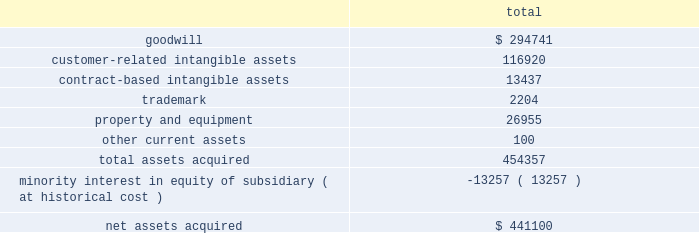Notes to consolidated financial statements 2014 ( continued ) merchant acquiring business in the united kingdom to the partnership .
In addition , hsbc uk entered into a ten-year marketing alliance with the partnership in which hsbc uk will refer customers to the partnership for payment processing services in the united kingdom .
On june 23 , 2008 , we entered into a new five year , $ 200 million term loan to fund a portion of the acquisition .
We funded the remaining purchase price with excess cash and our existing credit facilities .
The term loan bears interest , at our election , at the prime rate or london interbank offered rate plus a margin based on our leverage position .
As of july 1 , 2008 , the interest rate on the term loan was 3.605% ( 3.605 % ) .
The term loan calls for quarterly principal payments of $ 5 million beginning with the quarter ending august 31 , 2008 and increasing to $ 10 million beginning with the quarter ending august 31 , 2010 and $ 15 million beginning with the quarter ending august 31 , 2011 .
The partnership agreement includes provisions pursuant to which hsbc uk may compel us to purchase , at fair value , additional membership units from hsbc uk ( the 201cput option 201d ) .
Hsbc uk may exercise the put option on the fifth anniversary of the closing of the acquisition and on each anniversary thereafter .
By exercising the put option , hsbc uk can require us to purchase , on an annual basis , up to 15% ( 15 % ) of the total membership units .
Additionally , on the tenth anniversary of closing and each tenth anniversary thereafter , hsbc uk may compel us to purchase all of their membership units at fair value .
While not redeemable until june 2013 , we estimate the maximum total redemption amount of the minority interest under the put option would be $ 421.4 million , as of may 31 , 2008 .
The purpose of this acquisition was to establish a presence in the united kingdom .
The key factors that contributed to the decision to make this acquisition include historical and prospective financial statement analysis and hsbc uk 2019s market share and retail presence in the united kingdom .
The purchase price was determined by analyzing the historical and prospective financial statements and applying relevant purchase price multiples .
The purchase price totaled $ 441.1 million , consisting of $ 438.6 million cash consideration plus $ 2.5 million of direct out of pocket costs .
The acquisition has been recorded using the purchase method of accounting , and , accordingly , the purchase price has been allocated to the assets acquired and liabilities assumed based on their estimated fair values at the date of acquisition .
The table summarizes the preliminary purchase price allocation: .
Due to the recent timing of the transaction , the allocation of the purchase price is preliminary .
All of the goodwill associated with the acquisition is expected to be deductible for tax purposes .
The customer-related intangible assets have amortization periods of up to 13 years .
The contract-based intangible assets have amortization periods of 7 years .
The trademark has an amortization period of 5 years. .
What is the total amount of principle payment paid from 2008 to 2011? 
Rationale: to find the total amount of payments one must check line 7 and added up all the years from 2008 to 2011 .
Computations: ((5 + 10) + (5 + 10))
Answer: 30.0. 